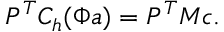Convert formula to latex. <formula><loc_0><loc_0><loc_500><loc_500>P ^ { T } C _ { h } ( \Phi a ) = P ^ { T } M c .</formula> 